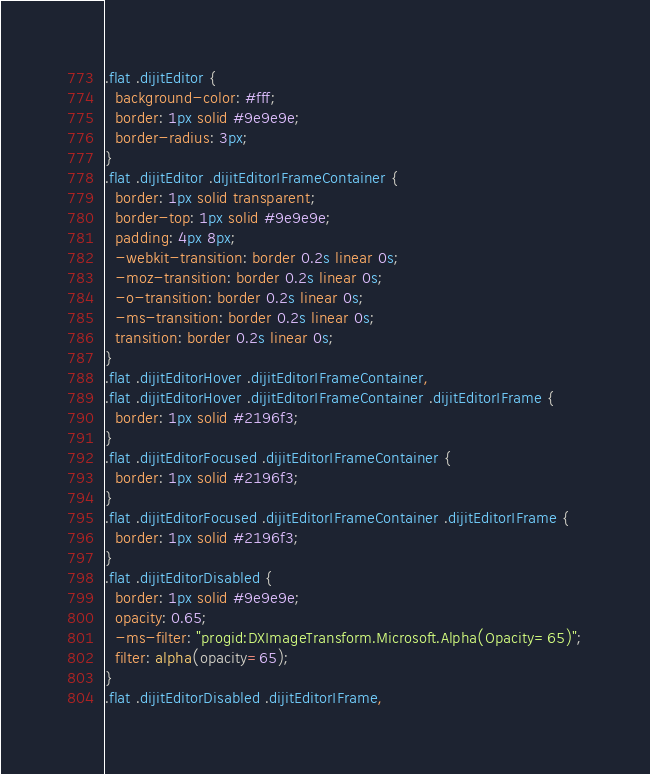<code> <loc_0><loc_0><loc_500><loc_500><_CSS_>
.flat .dijitEditor {
  background-color: #fff;
  border: 1px solid #9e9e9e;
  border-radius: 3px;
}
.flat .dijitEditor .dijitEditorIFrameContainer {
  border: 1px solid transparent;
  border-top: 1px solid #9e9e9e;
  padding: 4px 8px;
  -webkit-transition: border 0.2s linear 0s;
  -moz-transition: border 0.2s linear 0s;
  -o-transition: border 0.2s linear 0s;
  -ms-transition: border 0.2s linear 0s;
  transition: border 0.2s linear 0s;
}
.flat .dijitEditorHover .dijitEditorIFrameContainer,
.flat .dijitEditorHover .dijitEditorIFrameContainer .dijitEditorIFrame {
  border: 1px solid #2196f3;
}
.flat .dijitEditorFocused .dijitEditorIFrameContainer {
  border: 1px solid #2196f3;
}
.flat .dijitEditorFocused .dijitEditorIFrameContainer .dijitEditorIFrame {
  border: 1px solid #2196f3;
}
.flat .dijitEditorDisabled {
  border: 1px solid #9e9e9e;
  opacity: 0.65;
  -ms-filter: "progid:DXImageTransform.Microsoft.Alpha(Opacity=65)";
  filter: alpha(opacity=65);
}
.flat .dijitEditorDisabled .dijitEditorIFrame,</code> 